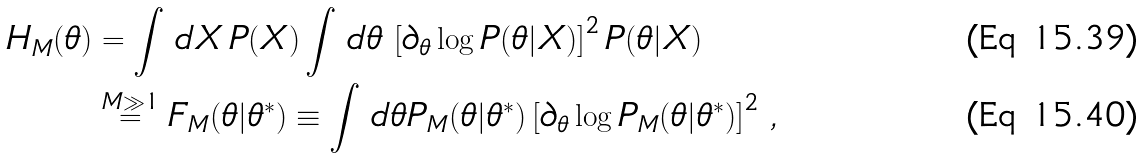Convert formula to latex. <formula><loc_0><loc_0><loc_500><loc_500>H _ { M } ( \theta ) & = \int \, d X \, P ( X ) \int \, d \theta \, \left [ \partial _ { \theta } \log P ( \theta | X ) \right ] ^ { 2 } P ( \theta | X ) \\ & \stackrel { M \gg 1 } { = } F _ { M } ( \theta | \theta ^ { * } ) \equiv \int \, d \theta P _ { M } ( \theta | \theta ^ { * } ) \left [ \partial _ { \theta } \log P _ { M } ( \theta | \theta ^ { * } ) \right ] ^ { 2 } \, ,</formula> 